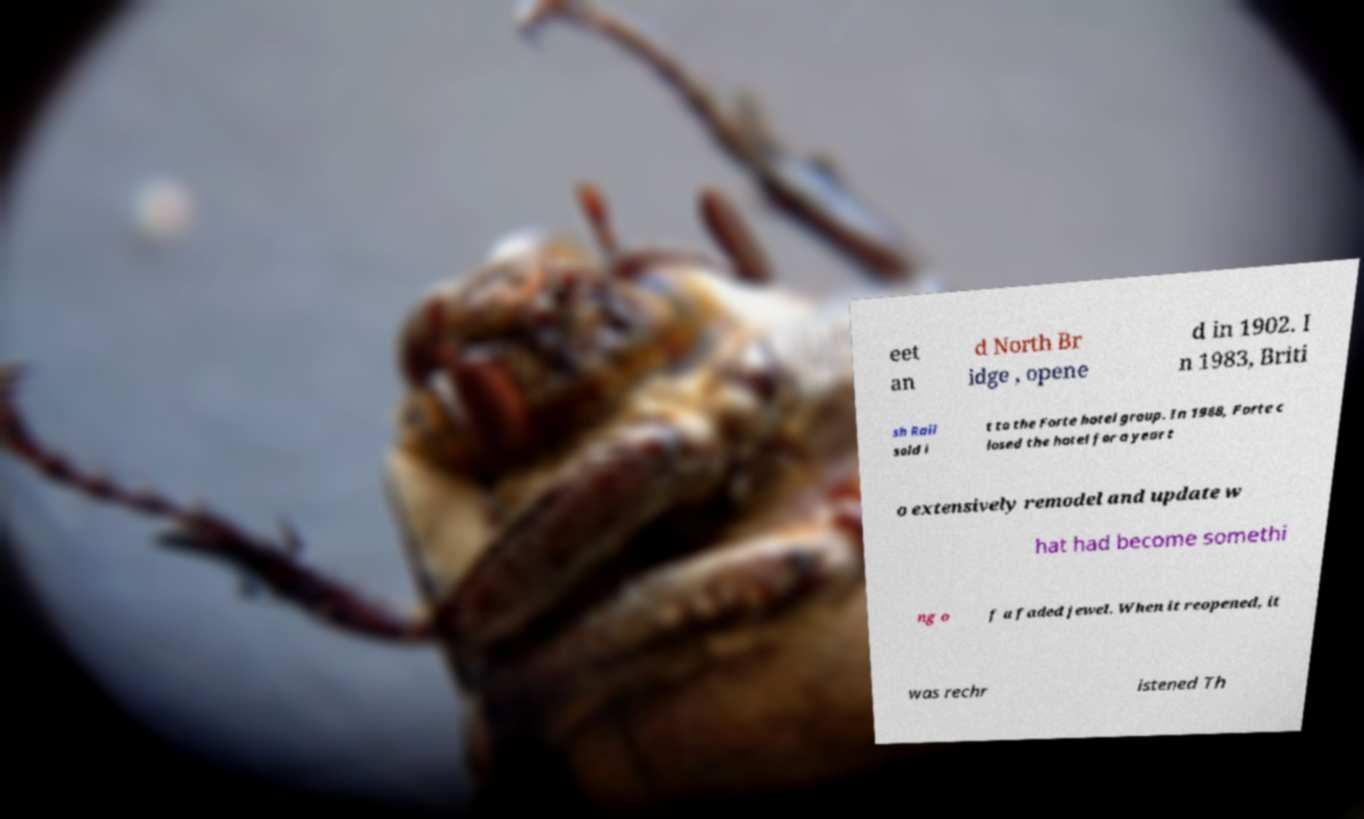Please read and relay the text visible in this image. What does it say? eet an d North Br idge , opene d in 1902. I n 1983, Briti sh Rail sold i t to the Forte hotel group. In 1988, Forte c losed the hotel for a year t o extensively remodel and update w hat had become somethi ng o f a faded jewel. When it reopened, it was rechr istened Th 